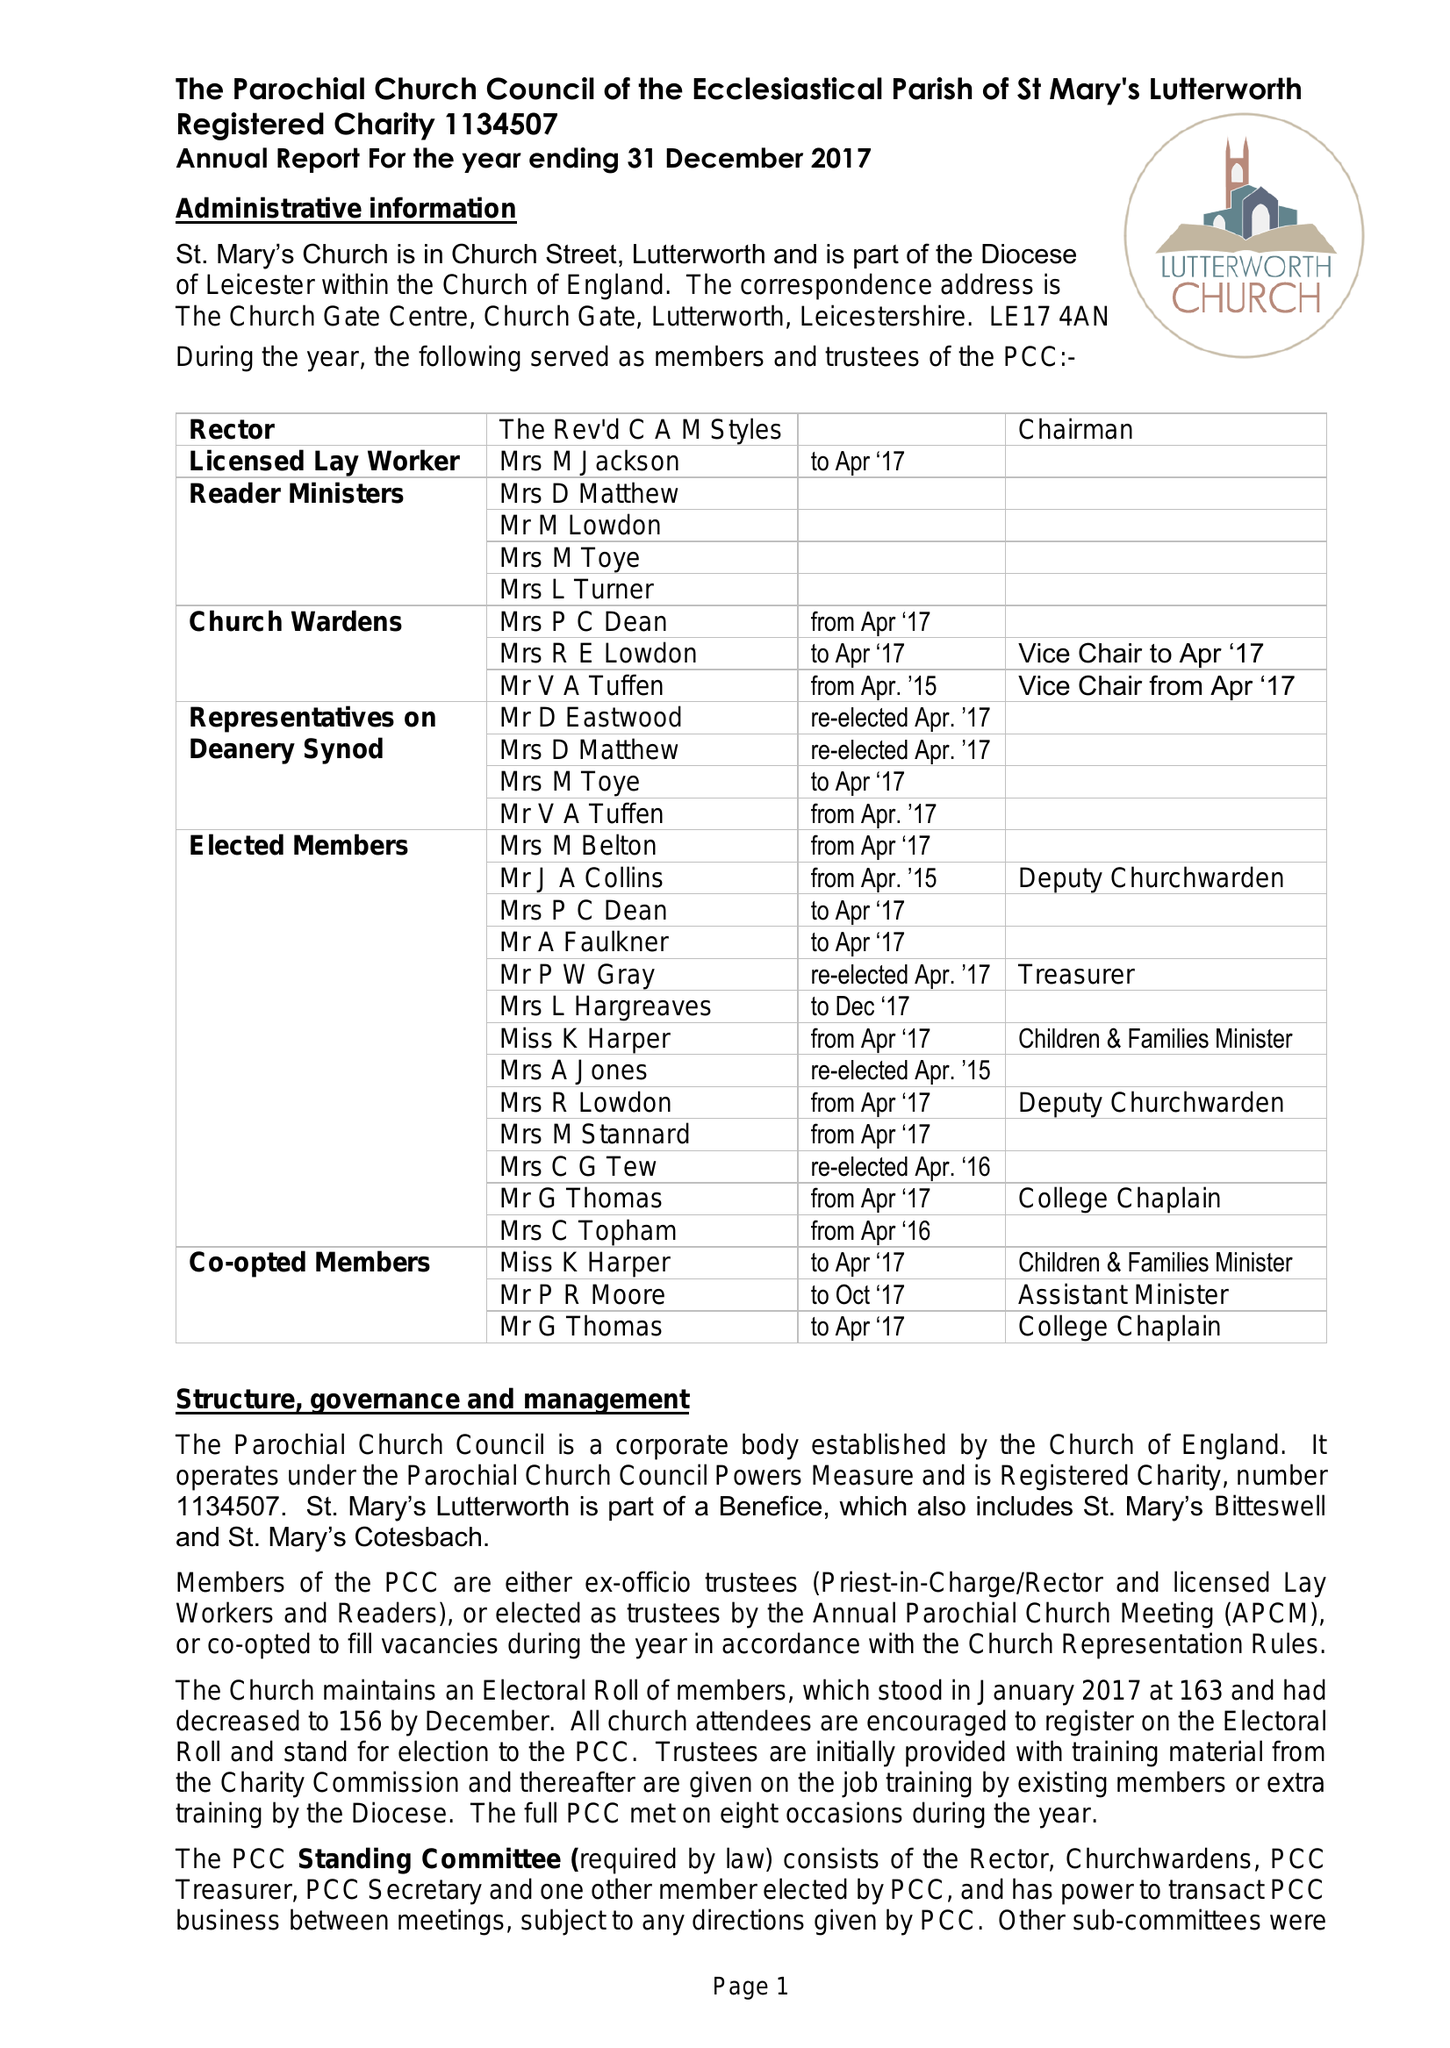What is the value for the report_date?
Answer the question using a single word or phrase. 2017-12-31 